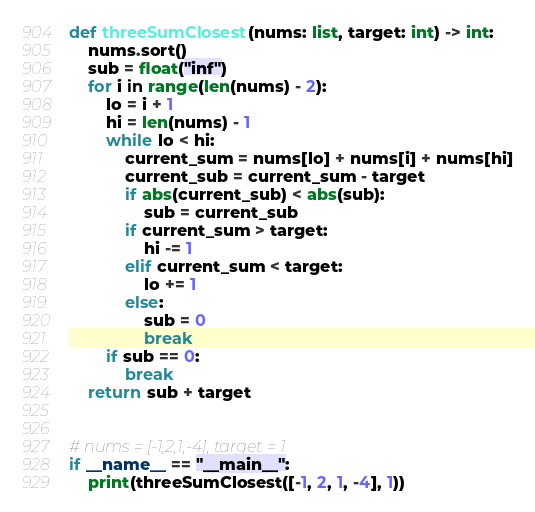<code> <loc_0><loc_0><loc_500><loc_500><_Python_>def threeSumClosest(nums: list, target: int) -> int:
    nums.sort()
    sub = float("inf")
    for i in range(len(nums) - 2):
        lo = i + 1
        hi = len(nums) - 1
        while lo < hi:
            current_sum = nums[lo] + nums[i] + nums[hi]
            current_sub = current_sum - target
            if abs(current_sub) < abs(sub):
                sub = current_sub
            if current_sum > target:
                hi -= 1
            elif current_sum < target:
                lo += 1
            else:
                sub = 0
                break
        if sub == 0:
            break
    return sub + target


# nums = [-1,2,1,-4], target = 1
if __name__ == "__main__":
    print(threeSumClosest([-1, 2, 1, -4], 1))
</code> 